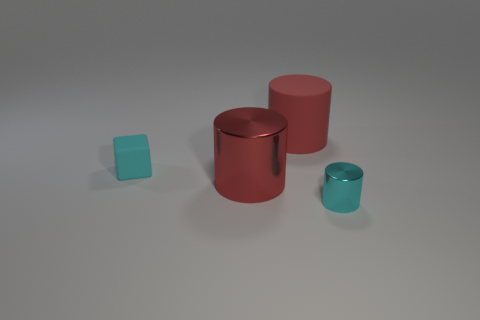Add 3 tiny brown metal cylinders. How many objects exist? 7 Subtract all cylinders. How many objects are left? 1 Add 3 red shiny objects. How many red shiny objects are left? 4 Add 4 cubes. How many cubes exist? 5 Subtract 0 gray balls. How many objects are left? 4 Subtract all tiny brown things. Subtract all tiny cyan metal cylinders. How many objects are left? 3 